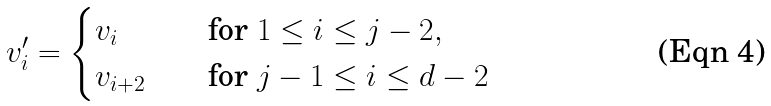<formula> <loc_0><loc_0><loc_500><loc_500>v _ { i } ^ { \prime } = \begin{cases} v _ { i } \quad & \text {for $1\leq i\leq j-2$} , \\ v _ { i + 2 } \quad & \text {for $j-1\leq i\leq d-2$} \end{cases}</formula> 